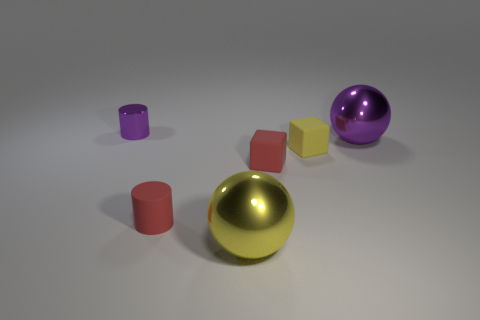What number of other objects are the same size as the red cylinder?
Provide a short and direct response. 3. What number of spheres are large yellow metallic things or purple shiny things?
Offer a terse response. 2. Is there any other thing that has the same material as the yellow cube?
Keep it short and to the point. Yes. What material is the red cube that is in front of the small cylinder that is on the left side of the red rubber thing in front of the small red cube made of?
Your answer should be compact. Rubber. What material is the tiny object that is the same color as the matte cylinder?
Give a very brief answer. Rubber. How many tiny red cylinders have the same material as the yellow block?
Your response must be concise. 1. Is the size of the cylinder that is in front of the purple metal sphere the same as the big yellow shiny thing?
Give a very brief answer. No. There is a tiny object that is made of the same material as the big purple ball; what color is it?
Offer a very short reply. Purple. How many large metallic objects are right of the big yellow shiny ball?
Offer a terse response. 1. Does the cylinder that is on the right side of the purple metal cylinder have the same color as the metallic sphere that is behind the large yellow metallic sphere?
Provide a succinct answer. No. 